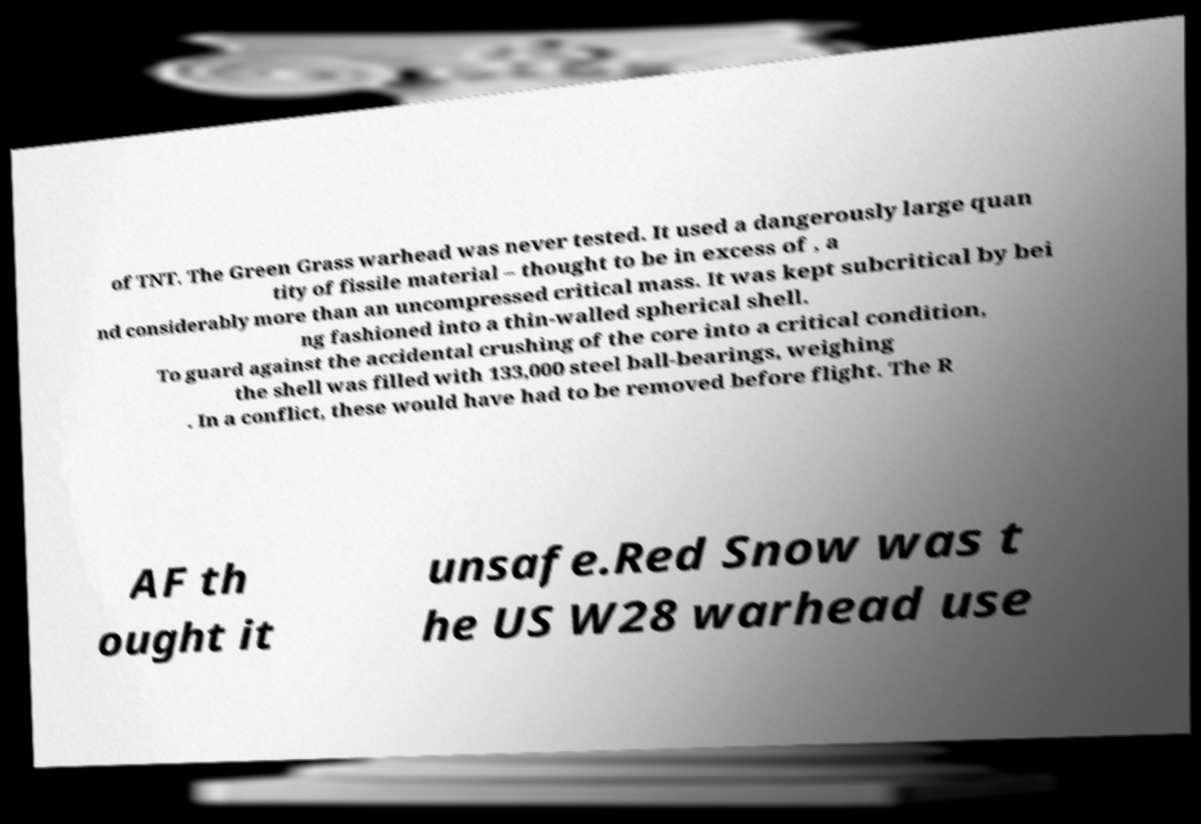For documentation purposes, I need the text within this image transcribed. Could you provide that? of TNT. The Green Grass warhead was never tested. It used a dangerously large quan tity of fissile material – thought to be in excess of , a nd considerably more than an uncompressed critical mass. It was kept subcritical by bei ng fashioned into a thin-walled spherical shell. To guard against the accidental crushing of the core into a critical condition, the shell was filled with 133,000 steel ball-bearings, weighing . In a conflict, these would have had to be removed before flight. The R AF th ought it unsafe.Red Snow was t he US W28 warhead use 